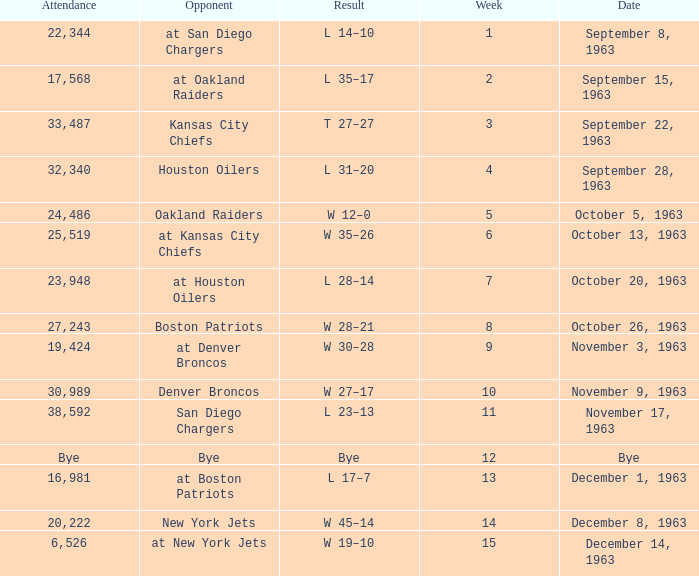Which competitor has a outcome of w 19-10? At new york jets. 